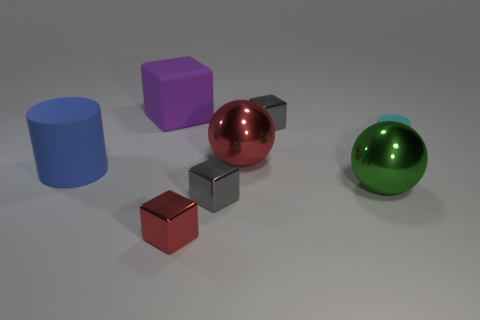Is the color of the small rubber cylinder the same as the matte object behind the tiny cyan cylinder?
Ensure brevity in your answer.  No. There is a object that is both left of the tiny red thing and in front of the large purple matte block; what is its size?
Your response must be concise. Large. How many other objects are there of the same color as the big cube?
Ensure brevity in your answer.  0. There is a shiny thing left of the small gray shiny cube that is on the left side of the shiny sphere to the left of the green metal ball; what size is it?
Offer a terse response. Small. There is a large green metal sphere; are there any large green balls in front of it?
Keep it short and to the point. No. There is a blue matte object; is its size the same as the gray cube that is in front of the green metal sphere?
Give a very brief answer. No. How many other objects are the same material as the green thing?
Make the answer very short. 4. What shape is the matte object that is both in front of the big rubber block and to the right of the big blue object?
Give a very brief answer. Cylinder. There is a gray metallic object in front of the large red metal sphere; is its size the same as the thing on the left side of the large purple object?
Your response must be concise. No. There is a big green object that is the same material as the large red object; what shape is it?
Your response must be concise. Sphere. 